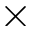<formula> <loc_0><loc_0><loc_500><loc_500>\times</formula> 